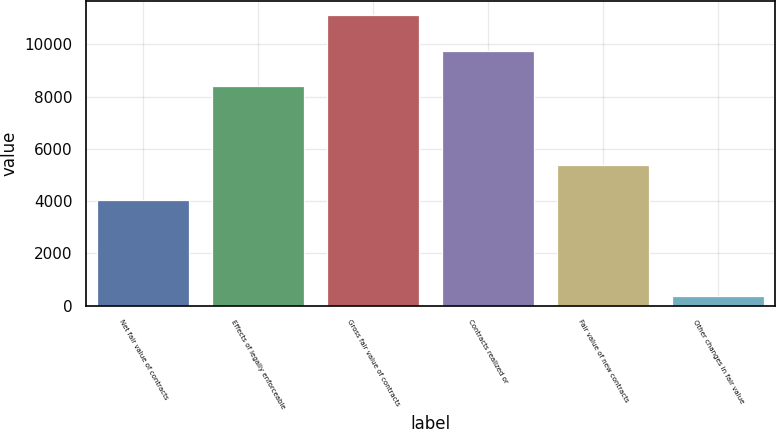Convert chart to OTSL. <chart><loc_0><loc_0><loc_500><loc_500><bar_chart><fcel>Net fair value of contracts<fcel>Effects of legally enforceable<fcel>Gross fair value of contracts<fcel>Contracts realized or<fcel>Fair value of new contracts<fcel>Other changes in fair value<nl><fcel>4041<fcel>8399<fcel>11107.4<fcel>9753.2<fcel>5395.2<fcel>365<nl></chart> 